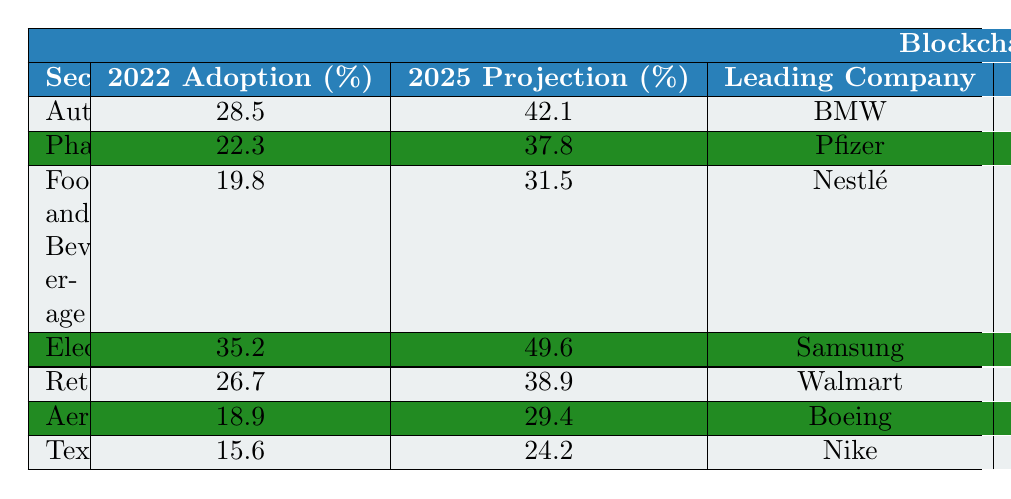What is the blockchain adoption rate in the electronic sector for 2022? The table shows that the adoption rate for the Electronics sector in 2022 is 35.2%.
Answer: 35.2% Which sector has the highest projected adoption rate in 2025? According to the table, the Electronics sector has the highest projected adoption rate in 2025 at 49.6%.
Answer: Electronics What is the average implementation time for adopting blockchain in the Textiles sector? The table lists the implementation time for the Textiles sector as 6 months.
Answer: 6 months Is the ROI for the Automotive sector higher than 20%? The Automotive sector has an ROI of 18.5%, which is lower than 20%.
Answer: No Which sector has the lowest adoption rate in 2022, and what is the rate? The Textiles sector has the lowest adoption rate in 2022 at 15.6%.
Answer: Textiles, 15.6% What is the difference in adoption rates between the Pharmaceuticals and Automotive sectors in 2022? The adoption rate for Pharmaceuticals is 22.3% and for Automotive is 28.5%. The difference is 28.5% - 22.3% = 6.2%.
Answer: 6.2% Which sector is using VeChain as the blockchain platform, and what is its primary use case? The Food and Beverage sector is using VeChain, and its primary use case is Farm-to-table tracking.
Answer: Food and Beverage, Farm-to-table tracking If the average ROI of all sectors is calculated, what is the percentage? Adding the ROI percentages gives: 18.5 + 15.2 + 12.7 + 20.3 + 16.9 + 14.1 + 11.8 = 109.5. There are 7 sectors, so the average ROI is 109.5 / 7 ≈ 15.64%.
Answer: 15.64% What is the major challenge faced by the Aerospace sector in blockchain adoption? The major challenge for the Aerospace sector according to the table is security concerns.
Answer: Security concerns Are all sectors projected to have an adoption rate above 25% by 2025? The projections indicate that the Textiles sector will have a rate of 24.2%, which is below 25%.
Answer: No 